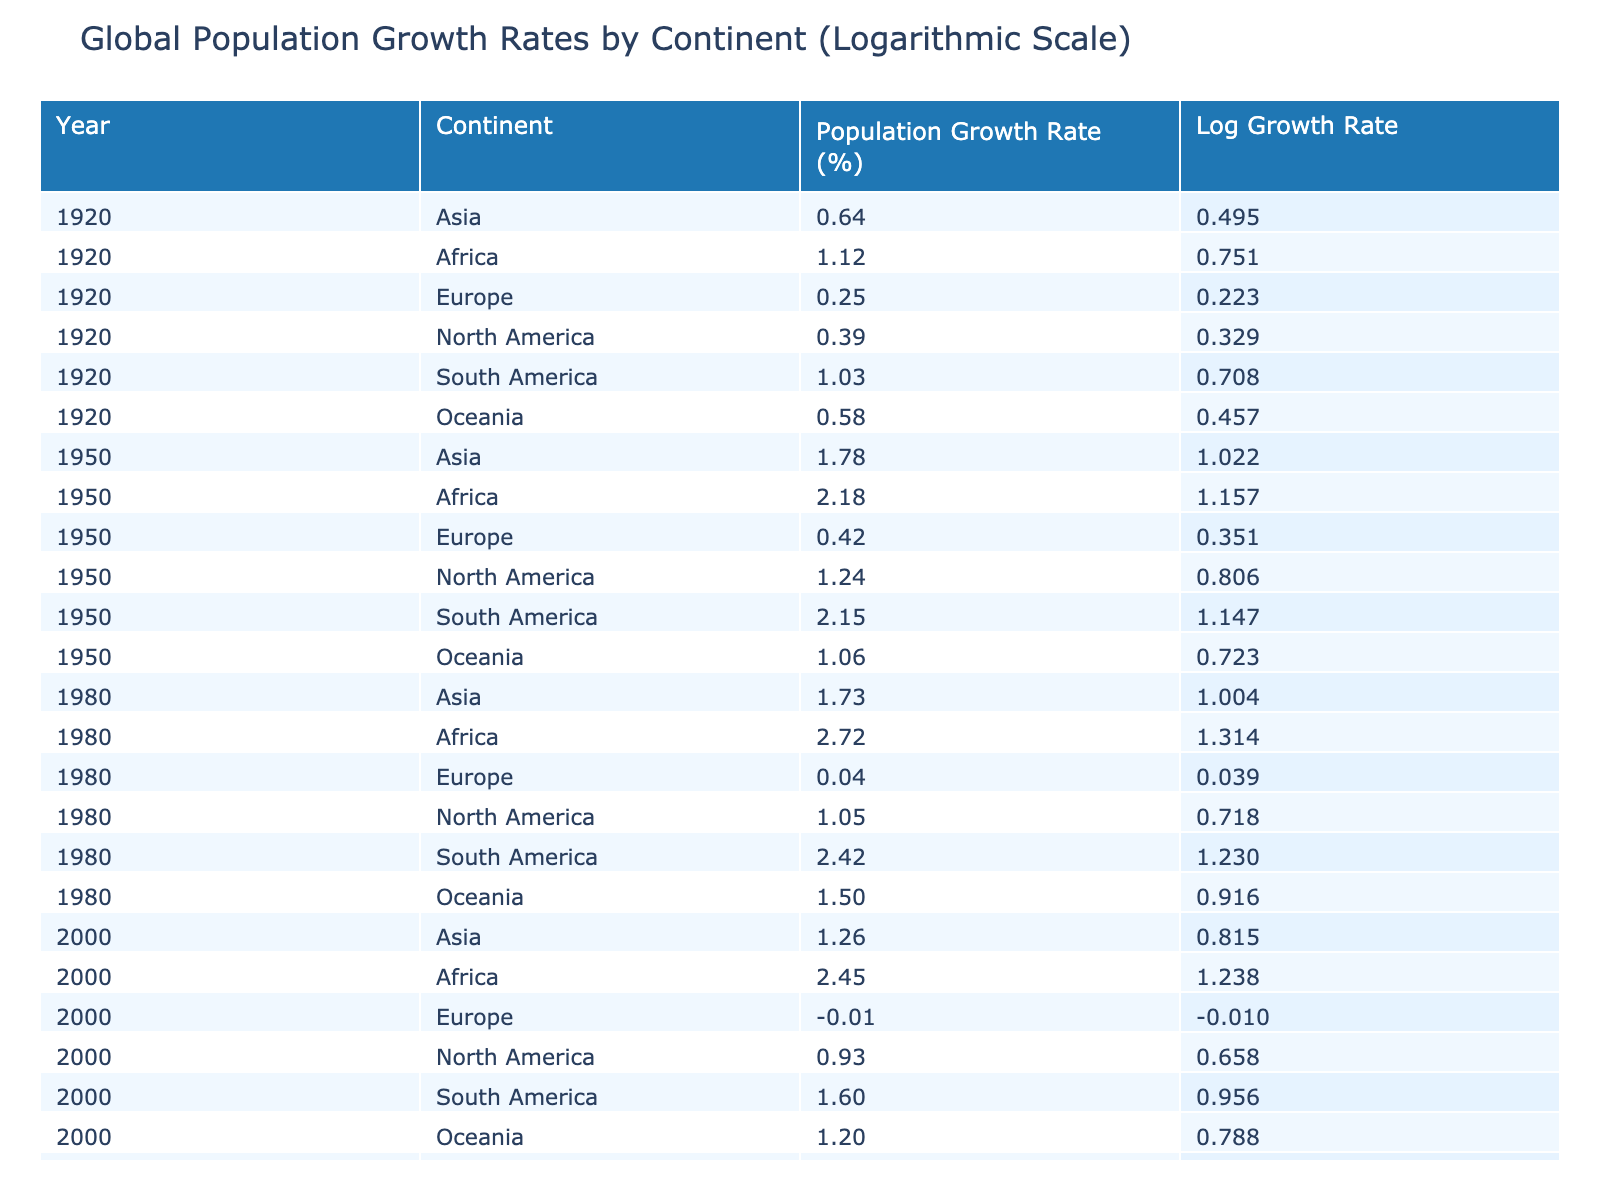What was the population growth rate of Africa in 1920? The table shows that in the year 1920, the population growth rate for Africa is listed as 1.12%.
Answer: 1.12% Which continent had the highest population growth rate in 1950? By comparing the growth rates in 1950, Africa (2.18%) has the highest rate compared to other continents.
Answer: Africa What is the average population growth rate for North America over the years provided? The growth rates for North America are 0.39%, 1.24%, 1.05%, 0.93%, 0.71%. Summing these gives 3.32%. Dividing by 5, the average is 3.32% / 5 = 0.664%.
Answer: 0.664% Did Europe experience a positive population growth rate at any point from 1920 to 2020? Based on the data, Europe had positive growth rates in 1920 (0.25%) and 1950 (0.42%), making the statement true.
Answer: Yes What is the difference in population growth rate for Asia between 2000 and 2020? The growth rate for Asia in 2000 was 1.26%, and in 2020 it was 0.92%. The difference is calculated as 1.26% - 0.92% = 0.34%.
Answer: 0.34% Which continent in 1980 had a population growth rate lower than 1%? Referring to the data for 1980, Europe had a population growth rate of 0.04%, which is less than 1%.
Answer: Europe How has the population growth rate for Africa changed from 1950 to 2020? In 1950, Africa's growth rate was 2.18%, and by 2020 it had slightly increased to 2.48%. This indicates there is an overall increase over this period.
Answer: Increased What was the trend in the population growth rates of Europe from 1950 to 2020? Europe had growth rates of 0.42% in 1950, decreasing to -0.01% in 2000, and further decreasing to -0.34% in 2020, showing a negative trend over these decades.
Answer: Negative trend 